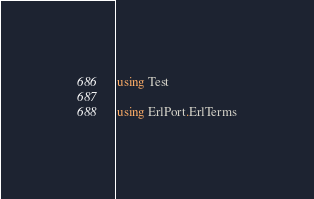<code> <loc_0><loc_0><loc_500><loc_500><_Julia_>using Test

using ErlPort.ErlTerms
</code> 